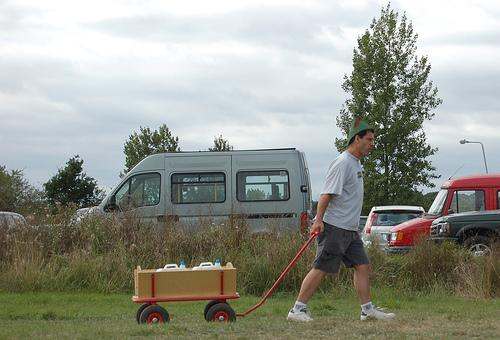Examine the footwear choices of the man, and mention their color. The man is wearing a pair of white tennis shoes. Identify the type of hat the man is wearing and its color. The man is wearing a green baseball cap with a pointed top. Mention the grassy area's details present in the image. There is a grassy area near the road with overgrown grass behind the trimmed grass. Identify the type, color, and position of the street light. It's a tall, white street light positioned in the background. Describe the various vehicles and their positions in the background. Numerous vehicles are parked in the background, including a gray van, a red van, and a big truck. Please provide a brief description of the scene depicted in the image. It's an outdoor scene with a man in grey pulling a red wagon, surrounded by numerous vehicles, tall grasses, trees, and a street light. How many visible trees are there, and what is their appearance? There is one large green tree and multiple trees in the background. What is the color and design of the vehicle behind the man? There is a large grey van facing left with windows and parked behind the man. List the details of the wagon being pulled by the man. The wagon is red with a wooden bottom, black tires with red centers, and a red, metal handle. What type of clothing is the man wearing and what is his primary activity? The man is dressed in grey and primarily pulling a little red wagon with his right hand. 